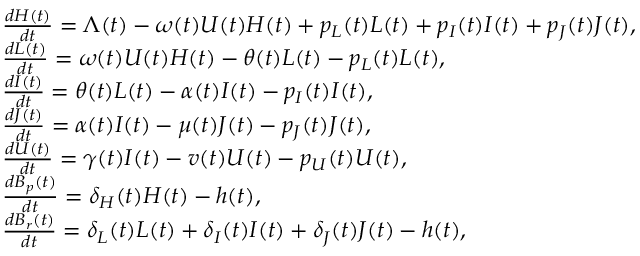<formula> <loc_0><loc_0><loc_500><loc_500>\begin{array} { l } { \frac { d H ( t ) } { d t } = \Lambda ( t ) - \omega ( t ) U ( t ) H ( t ) + p _ { L } ( t ) L ( t ) + p _ { I } ( t ) I ( t ) + p _ { J } ( t ) J ( t ) , } \\ { \frac { d L ( t ) } { d t } = \omega ( t ) U ( t ) H ( t ) - \theta ( t ) L ( t ) - p _ { L } ( t ) L ( t ) , } \\ { \frac { d I ( t ) } { d t } = \theta ( t ) L ( t ) - \alpha ( t ) I ( t ) - p _ { I } ( t ) I ( t ) , } \\ { \frac { d J ( t ) } { d t } = \alpha ( t ) I ( t ) - \mu ( t ) J ( t ) - p _ { J } ( t ) J ( t ) , } \\ { \frac { d U ( t ) } { d t } = \gamma ( t ) I ( t ) - v ( t ) U ( t ) - p _ { U } ( t ) U ( t ) , } \\ { \frac { d B _ { p } ( t ) } { d t } = \delta _ { H } ( t ) H ( t ) - h ( t ) , } \\ { \frac { d B _ { r } ( t ) } { d t } = \delta _ { L } ( t ) L ( t ) + \delta _ { I } ( t ) I ( t ) + \delta _ { J } ( t ) J ( t ) - h ( t ) , } \end{array}</formula> 